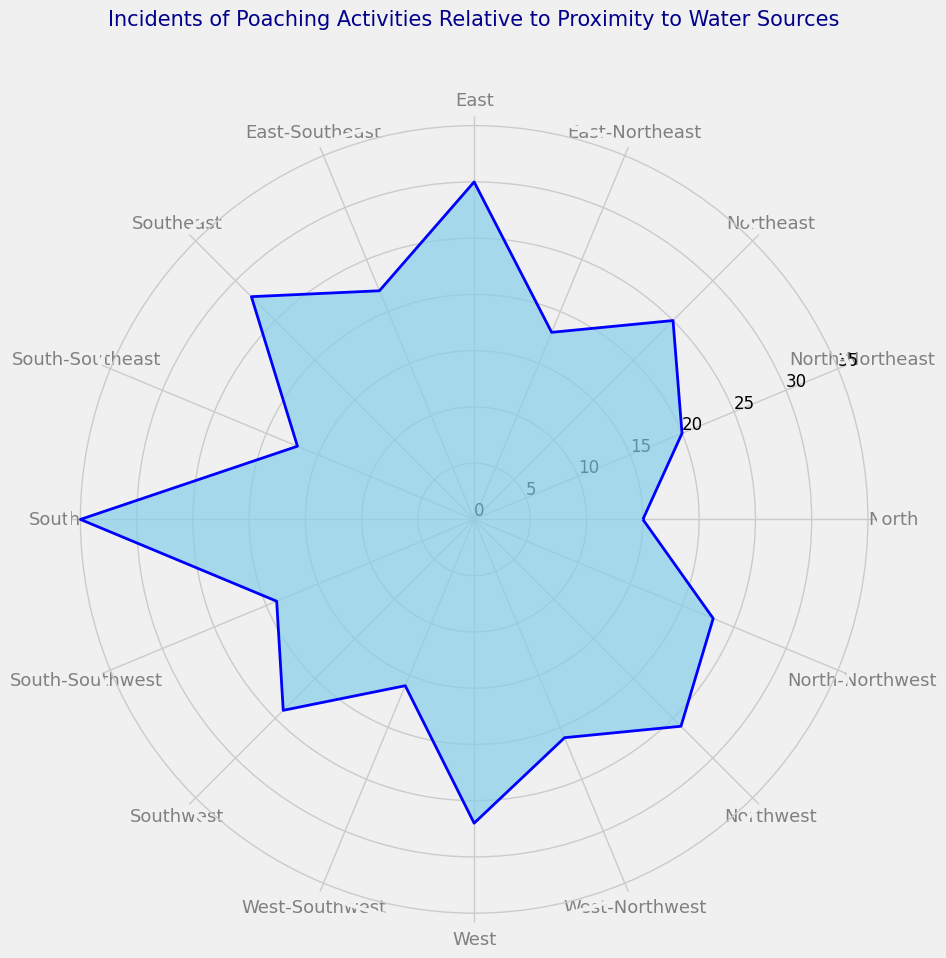What direction has the highest number of poaching incidents? First, identify the section on the chart that exhibits the highest extension from the center along the radial axis. The 'South' direction with 35 incidents stands out as the highest.
Answer: South Which direction has a higher number of poaching incidents: East or West? Compare the lengths of the radial extensions for 'East' (30 incidents) and 'West' (27 incidents). 'East' has a higher value.
Answer: East What's the difference in the number of poaching incidents between South and North? From the chart, find the 'South' direction with 35 incidents and 'North' with 15 incidents. Calculate the difference: 35 - 15 = 20.
Answer: 20 How many incidents are observed in the East-Southeast direction? Look at the radial section labeled 'East-Southeast.' It extends out to indicate 22 incidents.
Answer: 22 What is the average number of incidents in the Southeast and Southwest directions? Determine the incidents in the 'Southeast' direction (28) and 'Southwest' direction (24). Sum these (28 + 24 = 52) and get the average by dividing by 2: 52 / 2 = 26.
Answer: 26 Which direction showed more incidents: North-Northeast or North-Northwest? Compare 'North-Northeast' with 20 incidents and 'North-Northwest' with 23 incidents from the chart. 'North-Northwest' has more incidents.
Answer: North-Northwest In which direction do incidents increase continually: from North to South or South to North? Observe the plots and see incidents rising more significantly from North (15) to South (35) in comparison to the fluctuation when going from South to North.
Answer: North to South Are there more incidents in the Northern or Southern hemisphere directions? Sum the incident counts for directions in the Northern (North, North-Northeast, Northeast, East-Northeast, East, East-Southeast, Southeast, South-Southeast, Northwest, West-Northwest) and Southern (South, South-Southwest, Southwest, West-Southwest, West) hemispheres. Northern hemisphere: 15 + 20 + 25 + 18 + 30 + 22 + 28 + 17 + 26 + 23 = 224; Southern hemisphere: 35 + 19 + 24 + 16 + 27 = 121. Compare the sums.
Answer: Northern hemisphere What is the sum of incidents in the Western and Eastern directions including intermediaries? Western categories include West (27), West-Southwest (16), Southwest (24), West-Northwest (21), and Northwest (26). Sum these: 27 + 16 + 24 + 21 + 26 = 114. Eastern categories include East (30), East-Northeast (18), Northeast (25), East-Southeast (22), and Southeast (28). Sum these: 30 + 18 + 25 + 22 + 28 = 123. Provide the total: 114 + 123 = 237.
Answer: 237 